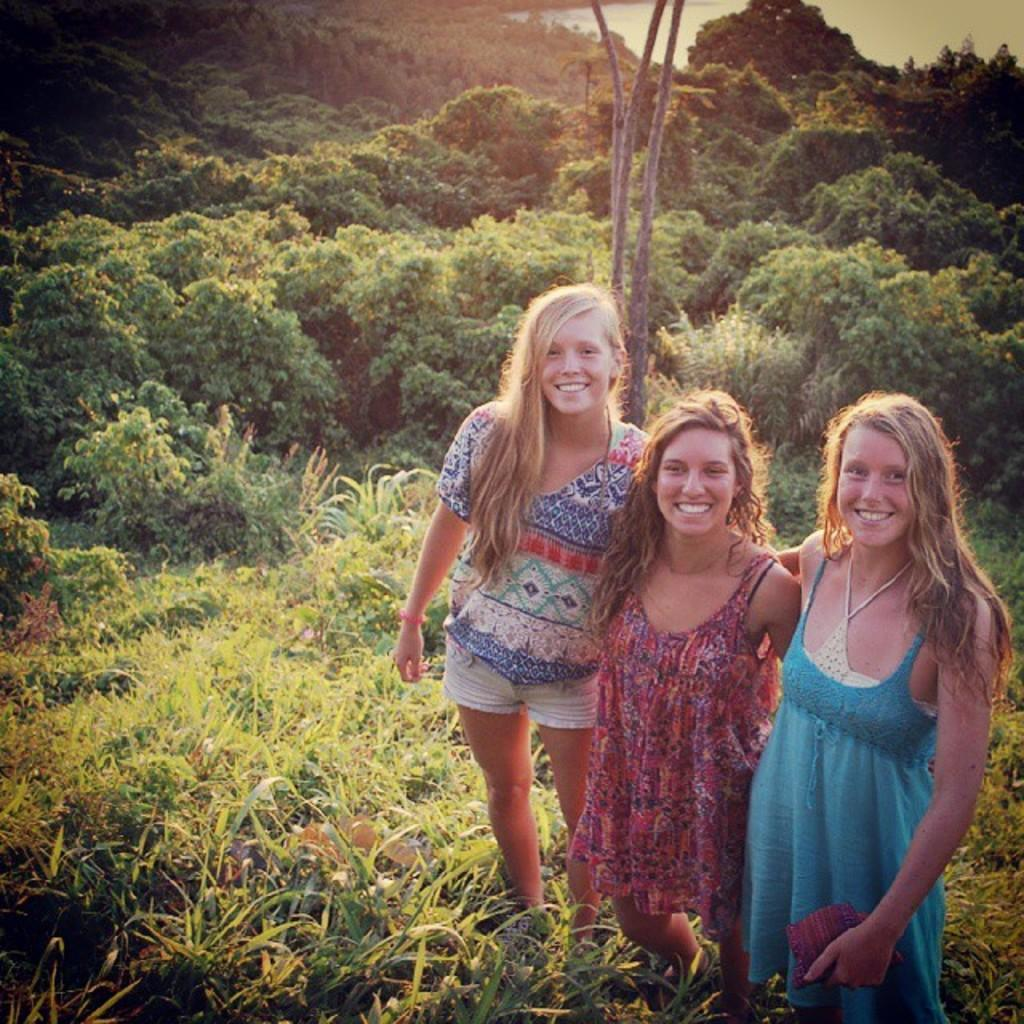How many people are in the image? There are three ladies in the image. What is the setting of the image? The ladies are standing on grassland. What can be seen in the background of the image? There are trees visible in the background of the image. What type of zipper can be seen on the trees in the image? There are no zippers present on the trees in the image; they are natural trees. 